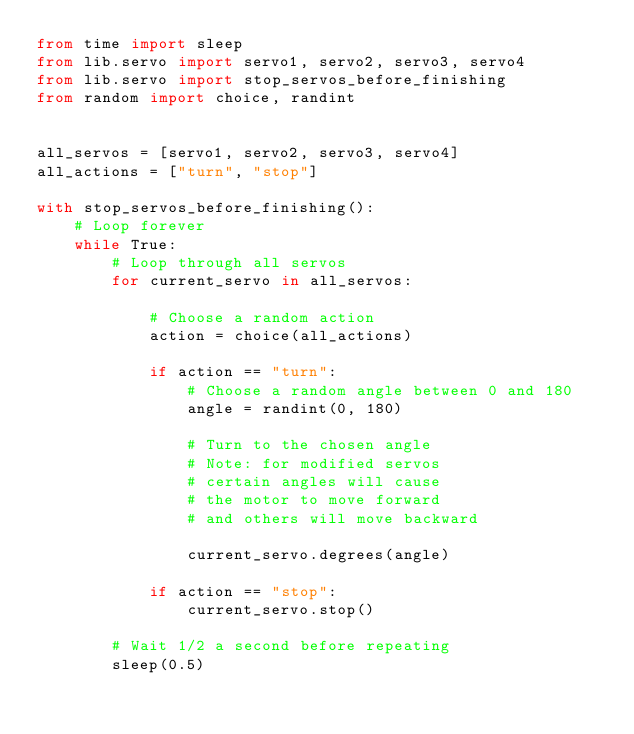Convert code to text. <code><loc_0><loc_0><loc_500><loc_500><_Python_>from time import sleep
from lib.servo import servo1, servo2, servo3, servo4
from lib.servo import stop_servos_before_finishing
from random import choice, randint


all_servos = [servo1, servo2, servo3, servo4]
all_actions = ["turn", "stop"]

with stop_servos_before_finishing():
    # Loop forever
    while True:
        # Loop through all servos
        for current_servo in all_servos:

            # Choose a random action
            action = choice(all_actions)

            if action == "turn":
                # Choose a random angle between 0 and 180
                angle = randint(0, 180)

                # Turn to the chosen angle
                # Note: for modified servos
                # certain angles will cause
                # the motor to move forward
                # and others will move backward

                current_servo.degrees(angle)

            if action == "stop":
                current_servo.stop()

        # Wait 1/2 a second before repeating
        sleep(0.5)
</code> 